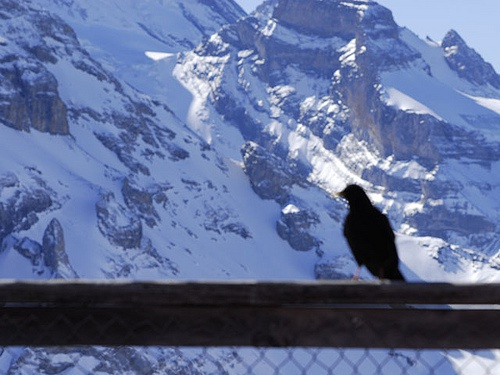Describe the objects in this image and their specific colors. I can see a bird in blue, black, gray, and navy tones in this image. 